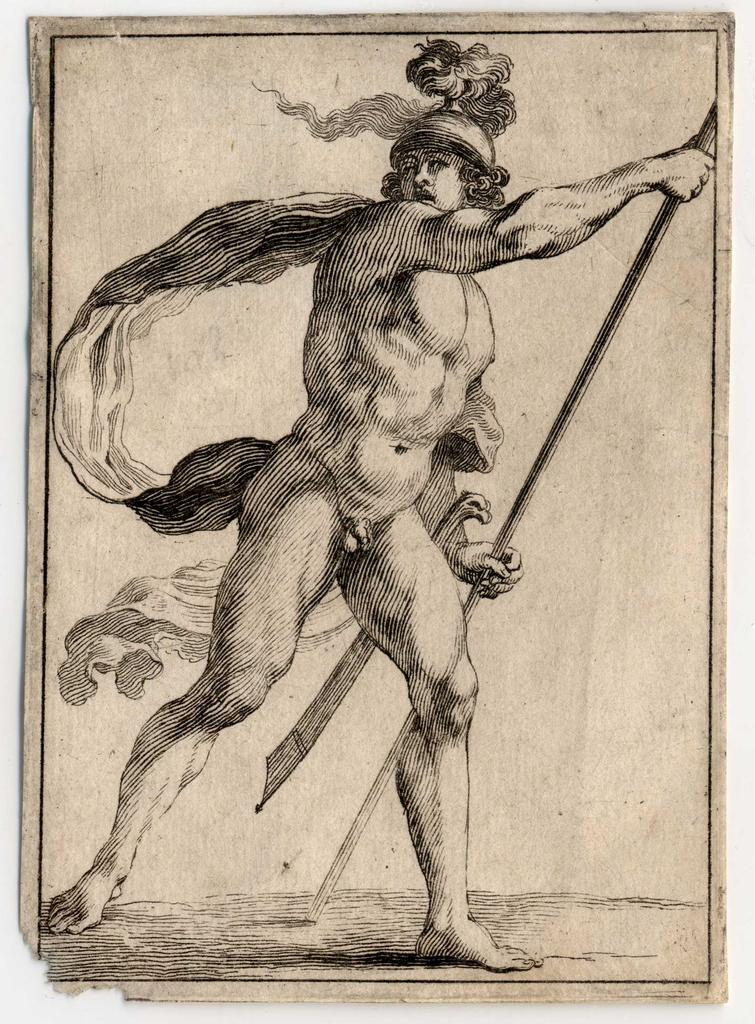What is the main subject of the sketch in the image? The main subject of the sketch in the image is a person. What is the person in the sketch holding? The person in the sketch is holding a stick. What color is the sketch? The sketch is in black color. What color is the background of the sketch? The background of the sketch is in cream color. What type of quill is the person using to draw the sketch in the image? There is no quill present in the image, as the sketch is not being drawn in the image. The person in the sketch is holding a stick, not a quill. Can you see any donkeys in the image? There are no donkeys present in the image; the sketch features a person holding a stick. 